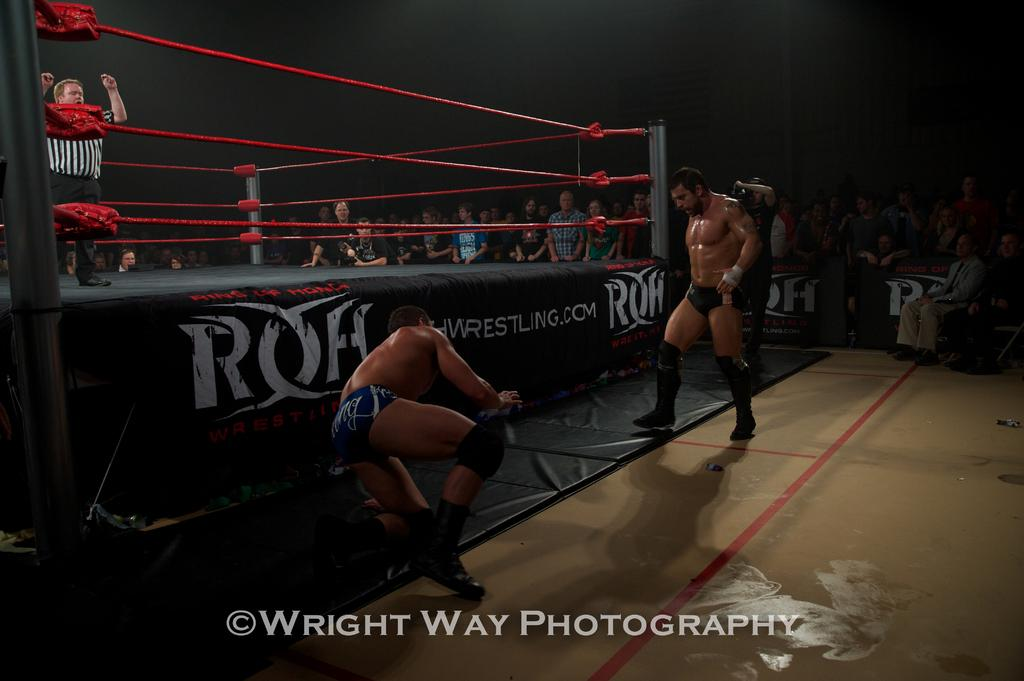<image>
Create a compact narrative representing the image presented. the word photography that is next to a ring 